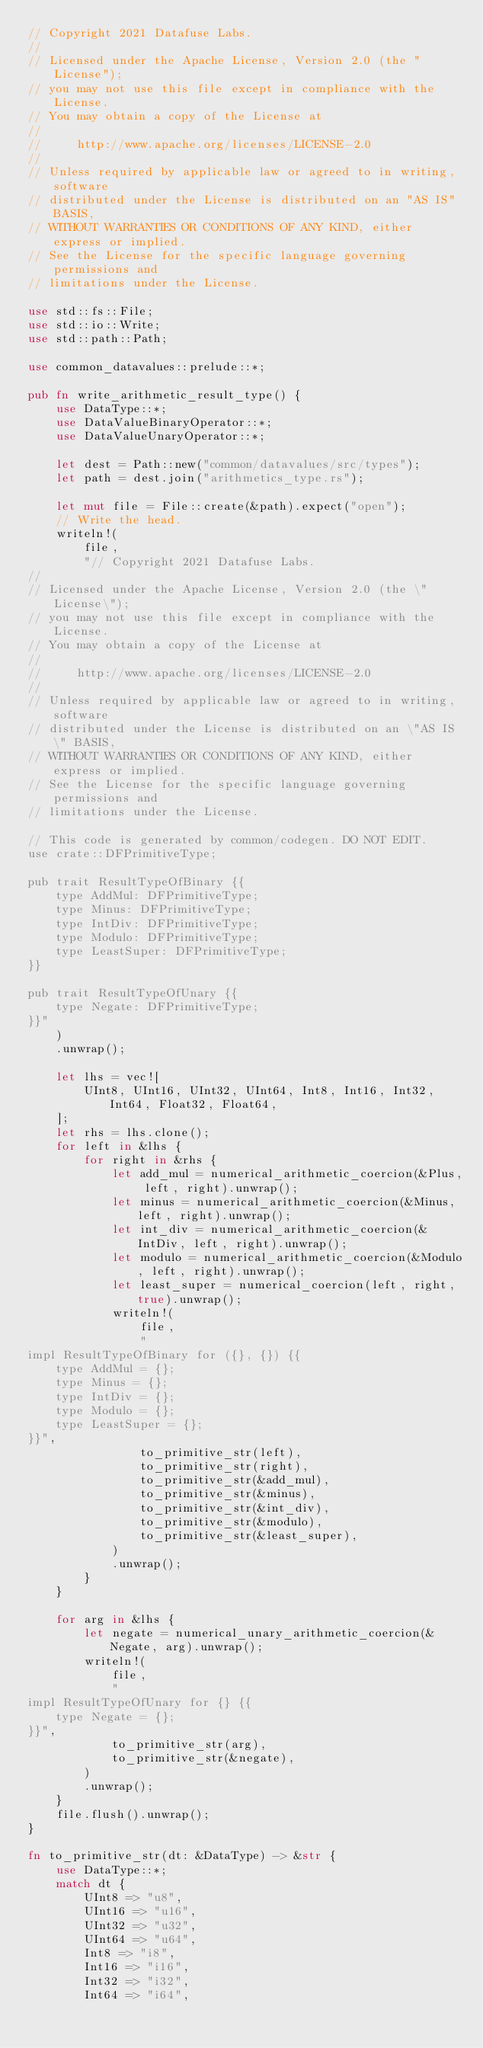Convert code to text. <code><loc_0><loc_0><loc_500><loc_500><_Rust_>// Copyright 2021 Datafuse Labs.
//
// Licensed under the Apache License, Version 2.0 (the "License");
// you may not use this file except in compliance with the License.
// You may obtain a copy of the License at
//
//     http://www.apache.org/licenses/LICENSE-2.0
//
// Unless required by applicable law or agreed to in writing, software
// distributed under the License is distributed on an "AS IS" BASIS,
// WITHOUT WARRANTIES OR CONDITIONS OF ANY KIND, either express or implied.
// See the License for the specific language governing permissions and
// limitations under the License.

use std::fs::File;
use std::io::Write;
use std::path::Path;

use common_datavalues::prelude::*;

pub fn write_arithmetic_result_type() {
    use DataType::*;
    use DataValueBinaryOperator::*;
    use DataValueUnaryOperator::*;

    let dest = Path::new("common/datavalues/src/types");
    let path = dest.join("arithmetics_type.rs");

    let mut file = File::create(&path).expect("open");
    // Write the head.
    writeln!(
        file,
        "// Copyright 2021 Datafuse Labs.
//
// Licensed under the Apache License, Version 2.0 (the \"License\");
// you may not use this file except in compliance with the License.
// You may obtain a copy of the License at
//
//     http://www.apache.org/licenses/LICENSE-2.0
//
// Unless required by applicable law or agreed to in writing, software
// distributed under the License is distributed on an \"AS IS\" BASIS,
// WITHOUT WARRANTIES OR CONDITIONS OF ANY KIND, either express or implied.
// See the License for the specific language governing permissions and
// limitations under the License.

// This code is generated by common/codegen. DO NOT EDIT.
use crate::DFPrimitiveType;

pub trait ResultTypeOfBinary {{
    type AddMul: DFPrimitiveType;
    type Minus: DFPrimitiveType;
    type IntDiv: DFPrimitiveType;
    type Modulo: DFPrimitiveType;
    type LeastSuper: DFPrimitiveType;
}}

pub trait ResultTypeOfUnary {{
    type Negate: DFPrimitiveType;
}}"
    )
    .unwrap();

    let lhs = vec![
        UInt8, UInt16, UInt32, UInt64, Int8, Int16, Int32, Int64, Float32, Float64,
    ];
    let rhs = lhs.clone();
    for left in &lhs {
        for right in &rhs {
            let add_mul = numerical_arithmetic_coercion(&Plus, left, right).unwrap();
            let minus = numerical_arithmetic_coercion(&Minus, left, right).unwrap();
            let int_div = numerical_arithmetic_coercion(&IntDiv, left, right).unwrap();
            let modulo = numerical_arithmetic_coercion(&Modulo, left, right).unwrap();
            let least_super = numerical_coercion(left, right, true).unwrap();
            writeln!(
                file,
                "
impl ResultTypeOfBinary for ({}, {}) {{
    type AddMul = {};
    type Minus = {};
    type IntDiv = {};
    type Modulo = {};
    type LeastSuper = {};
}}",
                to_primitive_str(left),
                to_primitive_str(right),
                to_primitive_str(&add_mul),
                to_primitive_str(&minus),
                to_primitive_str(&int_div),
                to_primitive_str(&modulo),
                to_primitive_str(&least_super),
            )
            .unwrap();
        }
    }

    for arg in &lhs {
        let negate = numerical_unary_arithmetic_coercion(&Negate, arg).unwrap();
        writeln!(
            file,
            "
impl ResultTypeOfUnary for {} {{
    type Negate = {};
}}",
            to_primitive_str(arg),
            to_primitive_str(&negate),
        )
        .unwrap();
    }
    file.flush().unwrap();
}

fn to_primitive_str(dt: &DataType) -> &str {
    use DataType::*;
    match dt {
        UInt8 => "u8",
        UInt16 => "u16",
        UInt32 => "u32",
        UInt64 => "u64",
        Int8 => "i8",
        Int16 => "i16",
        Int32 => "i32",
        Int64 => "i64",</code> 